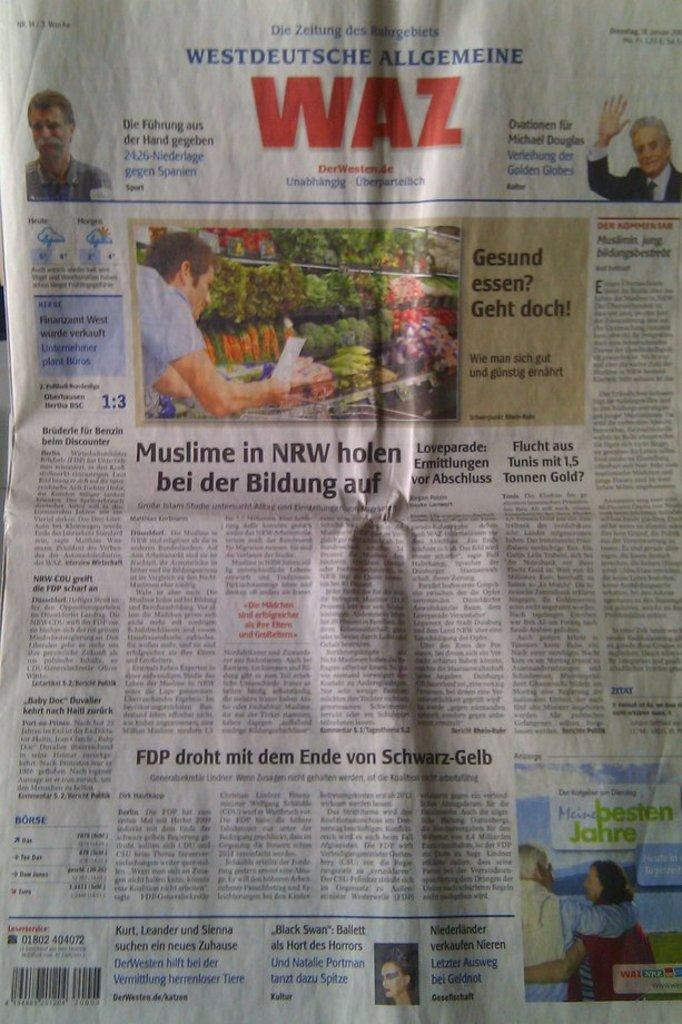What is the main object in the image? There is a newspaper in the image. What types of content can be found in the newspaper? The newspaper contains pictures and text. What is the purpose of the push in the image? There is no push present in the image; it only contains a newspaper with pictures and text. 